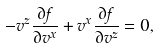Convert formula to latex. <formula><loc_0><loc_0><loc_500><loc_500>- v ^ { z } \frac { \partial f } { \partial v ^ { x } } + v ^ { x } \frac { \partial f } { \partial v ^ { z } } = 0 ,</formula> 